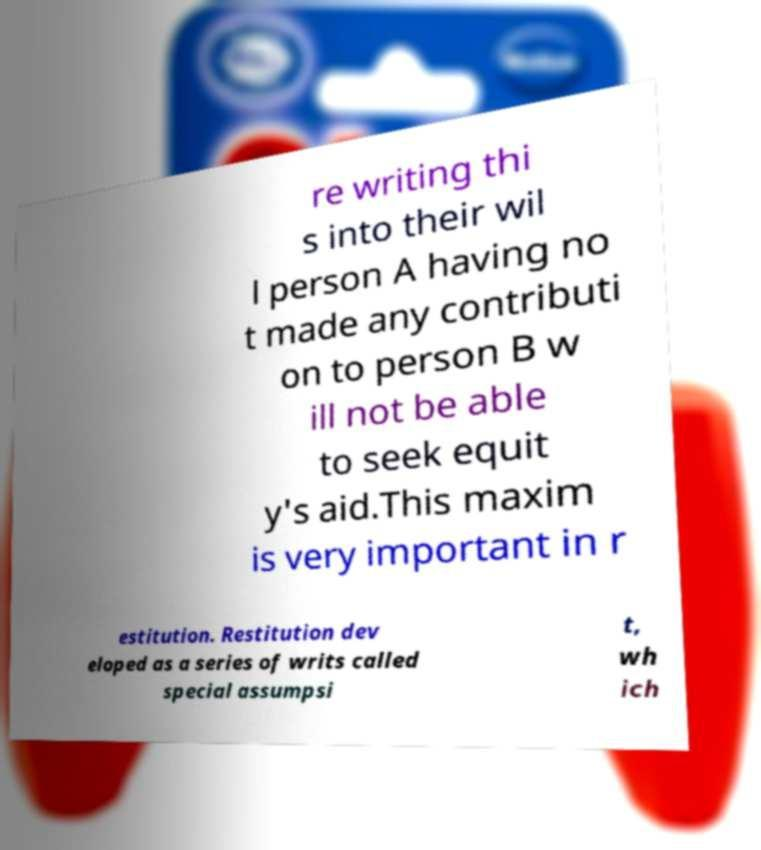Can you accurately transcribe the text from the provided image for me? re writing thi s into their wil l person A having no t made any contributi on to person B w ill not be able to seek equit y's aid.This maxim is very important in r estitution. Restitution dev eloped as a series of writs called special assumpsi t, wh ich 